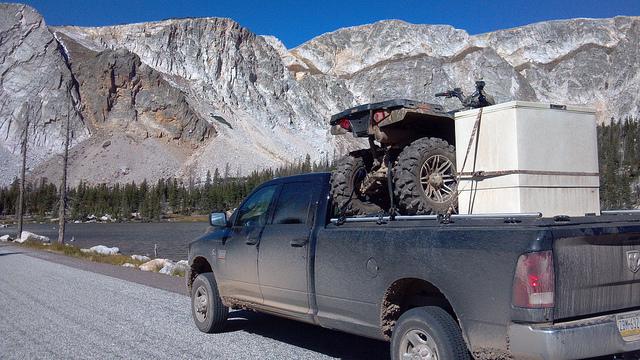What is the make and model of the truck shown in the picture?
Concise answer only. Dodge ram. Are the mountains snowy?
Write a very short answer. Yes. IS there an ATV in the picture?
Answer briefly. Yes. 